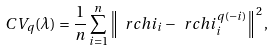<formula> <loc_0><loc_0><loc_500><loc_500>C V _ { q } ( \lambda ) = \frac { 1 } { n } \sum _ { i = 1 } ^ { n } \left \| \ r c h i _ { i } - \ r c h i _ { i } ^ { q ( - i ) } \right \| ^ { 2 } ,</formula> 